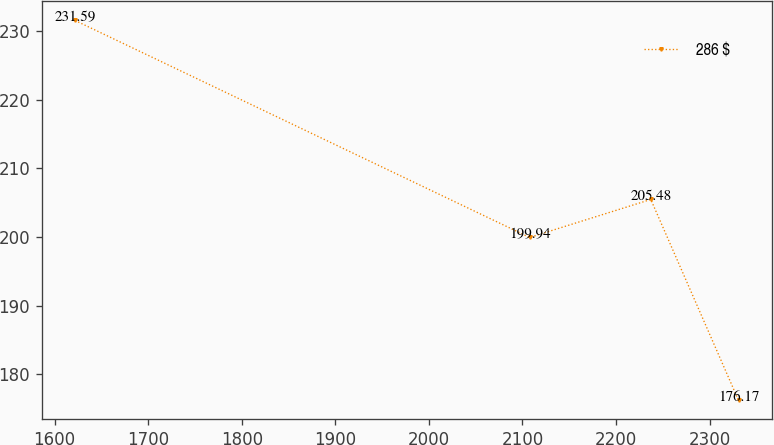Convert chart to OTSL. <chart><loc_0><loc_0><loc_500><loc_500><line_chart><ecel><fcel>286 $<nl><fcel>1621.76<fcel>231.59<nl><fcel>2107.64<fcel>199.94<nl><fcel>2237.1<fcel>205.48<nl><fcel>2330.9<fcel>176.17<nl></chart> 